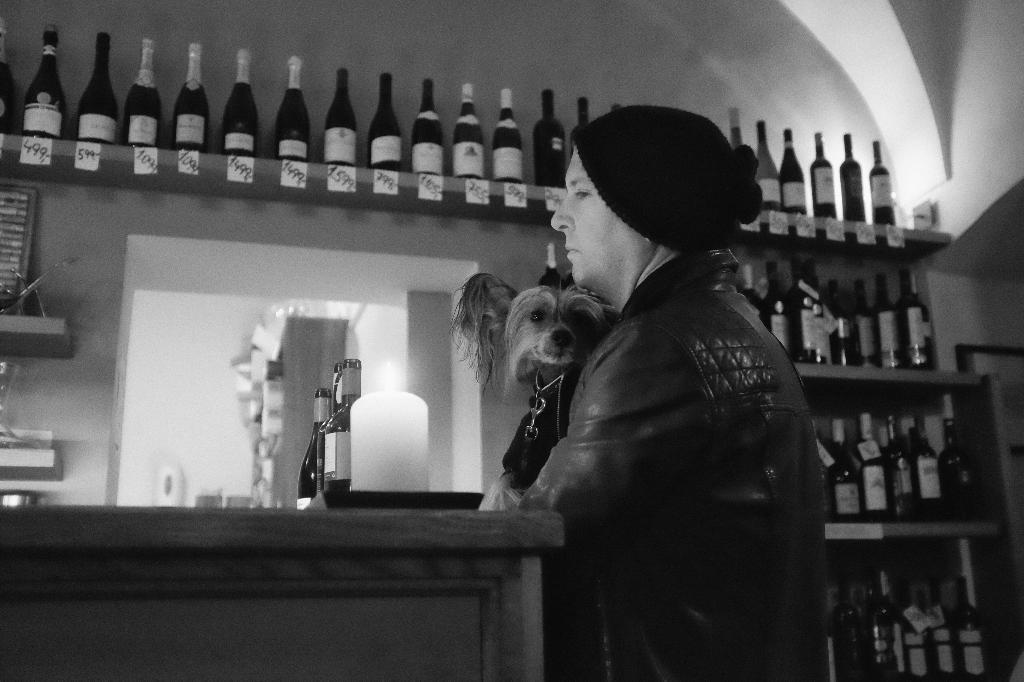Describe this image in one or two sentences. He is a man holding a dog in his hand. These are wine bottles. This is a wooden table where a few wine bottles are kept on it. 